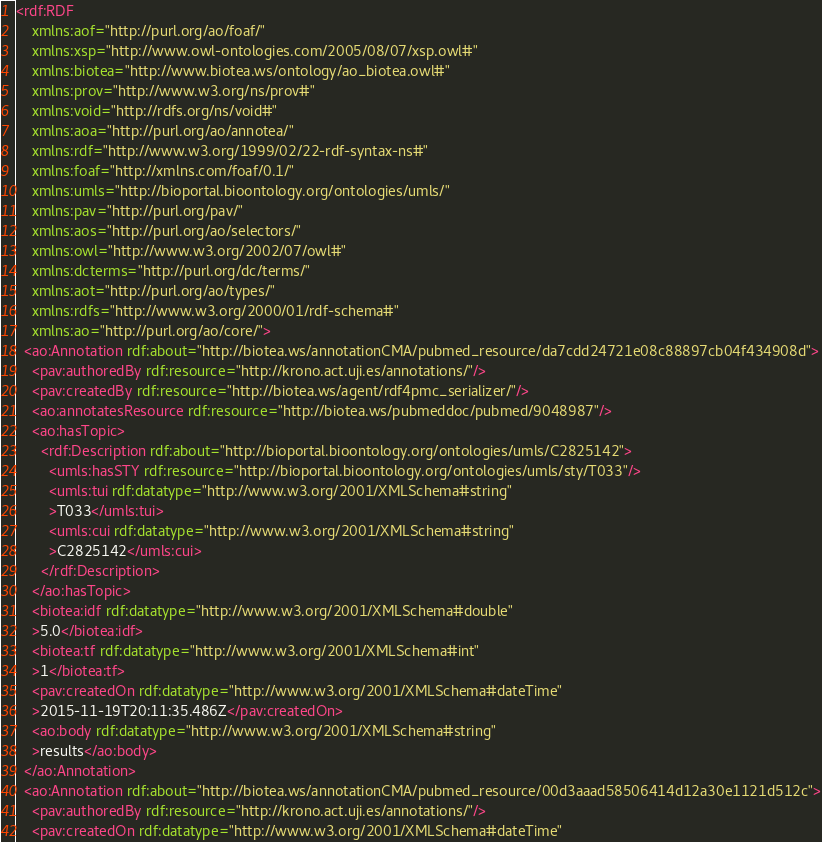Convert code to text. <code><loc_0><loc_0><loc_500><loc_500><_XML_><rdf:RDF
    xmlns:aof="http://purl.org/ao/foaf/"
    xmlns:xsp="http://www.owl-ontologies.com/2005/08/07/xsp.owl#"
    xmlns:biotea="http://www.biotea.ws/ontology/ao_biotea.owl#"
    xmlns:prov="http://www.w3.org/ns/prov#"
    xmlns:void="http://rdfs.org/ns/void#"
    xmlns:aoa="http://purl.org/ao/annotea/"
    xmlns:rdf="http://www.w3.org/1999/02/22-rdf-syntax-ns#"
    xmlns:foaf="http://xmlns.com/foaf/0.1/"
    xmlns:umls="http://bioportal.bioontology.org/ontologies/umls/"
    xmlns:pav="http://purl.org/pav/"
    xmlns:aos="http://purl.org/ao/selectors/"
    xmlns:owl="http://www.w3.org/2002/07/owl#"
    xmlns:dcterms="http://purl.org/dc/terms/"
    xmlns:aot="http://purl.org/ao/types/"
    xmlns:rdfs="http://www.w3.org/2000/01/rdf-schema#"
    xmlns:ao="http://purl.org/ao/core/">
  <ao:Annotation rdf:about="http://biotea.ws/annotationCMA/pubmed_resource/da7cdd24721e08c88897cb04f434908d">
    <pav:authoredBy rdf:resource="http://krono.act.uji.es/annotations/"/>
    <pav:createdBy rdf:resource="http://biotea.ws/agent/rdf4pmc_serializer/"/>
    <ao:annotatesResource rdf:resource="http://biotea.ws/pubmeddoc/pubmed/9048987"/>
    <ao:hasTopic>
      <rdf:Description rdf:about="http://bioportal.bioontology.org/ontologies/umls/C2825142">
        <umls:hasSTY rdf:resource="http://bioportal.bioontology.org/ontologies/umls/sty/T033"/>
        <umls:tui rdf:datatype="http://www.w3.org/2001/XMLSchema#string"
        >T033</umls:tui>
        <umls:cui rdf:datatype="http://www.w3.org/2001/XMLSchema#string"
        >C2825142</umls:cui>
      </rdf:Description>
    </ao:hasTopic>
    <biotea:idf rdf:datatype="http://www.w3.org/2001/XMLSchema#double"
    >5.0</biotea:idf>
    <biotea:tf rdf:datatype="http://www.w3.org/2001/XMLSchema#int"
    >1</biotea:tf>
    <pav:createdOn rdf:datatype="http://www.w3.org/2001/XMLSchema#dateTime"
    >2015-11-19T20:11:35.486Z</pav:createdOn>
    <ao:body rdf:datatype="http://www.w3.org/2001/XMLSchema#string"
    >results</ao:body>
  </ao:Annotation>
  <ao:Annotation rdf:about="http://biotea.ws/annotationCMA/pubmed_resource/00d3aaad58506414d12a30e1121d512c">
    <pav:authoredBy rdf:resource="http://krono.act.uji.es/annotations/"/>
    <pav:createdOn rdf:datatype="http://www.w3.org/2001/XMLSchema#dateTime"</code> 